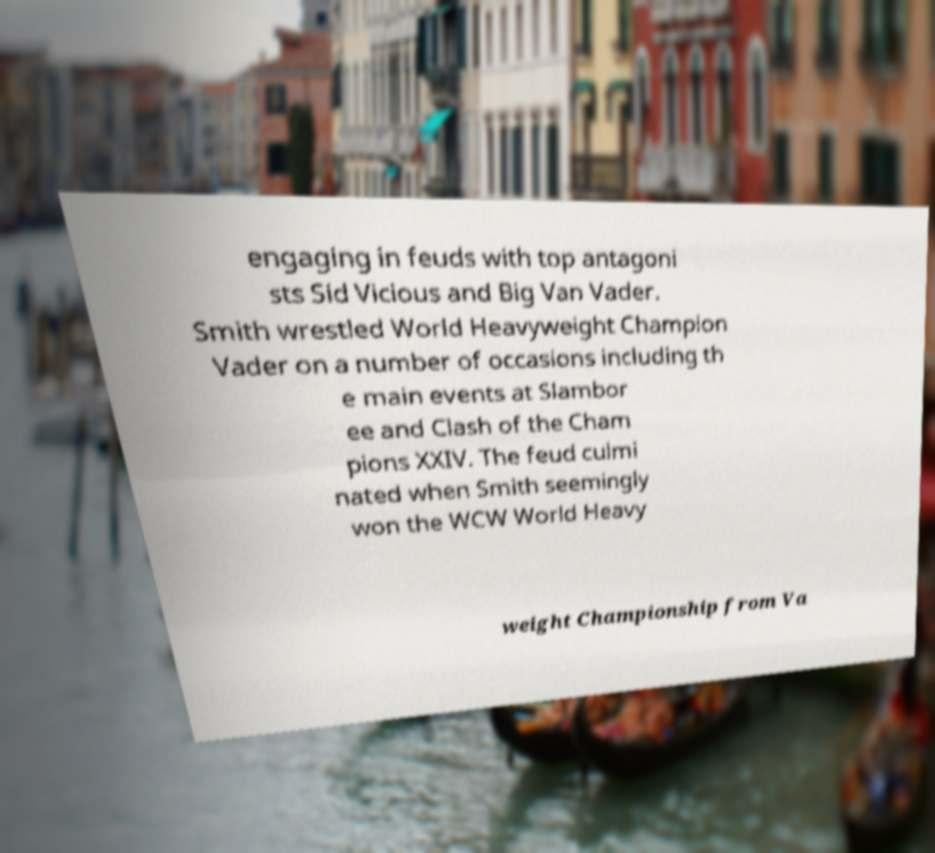Can you accurately transcribe the text from the provided image for me? engaging in feuds with top antagoni sts Sid Vicious and Big Van Vader. Smith wrestled World Heavyweight Champion Vader on a number of occasions including th e main events at Slambor ee and Clash of the Cham pions XXIV. The feud culmi nated when Smith seemingly won the WCW World Heavy weight Championship from Va 